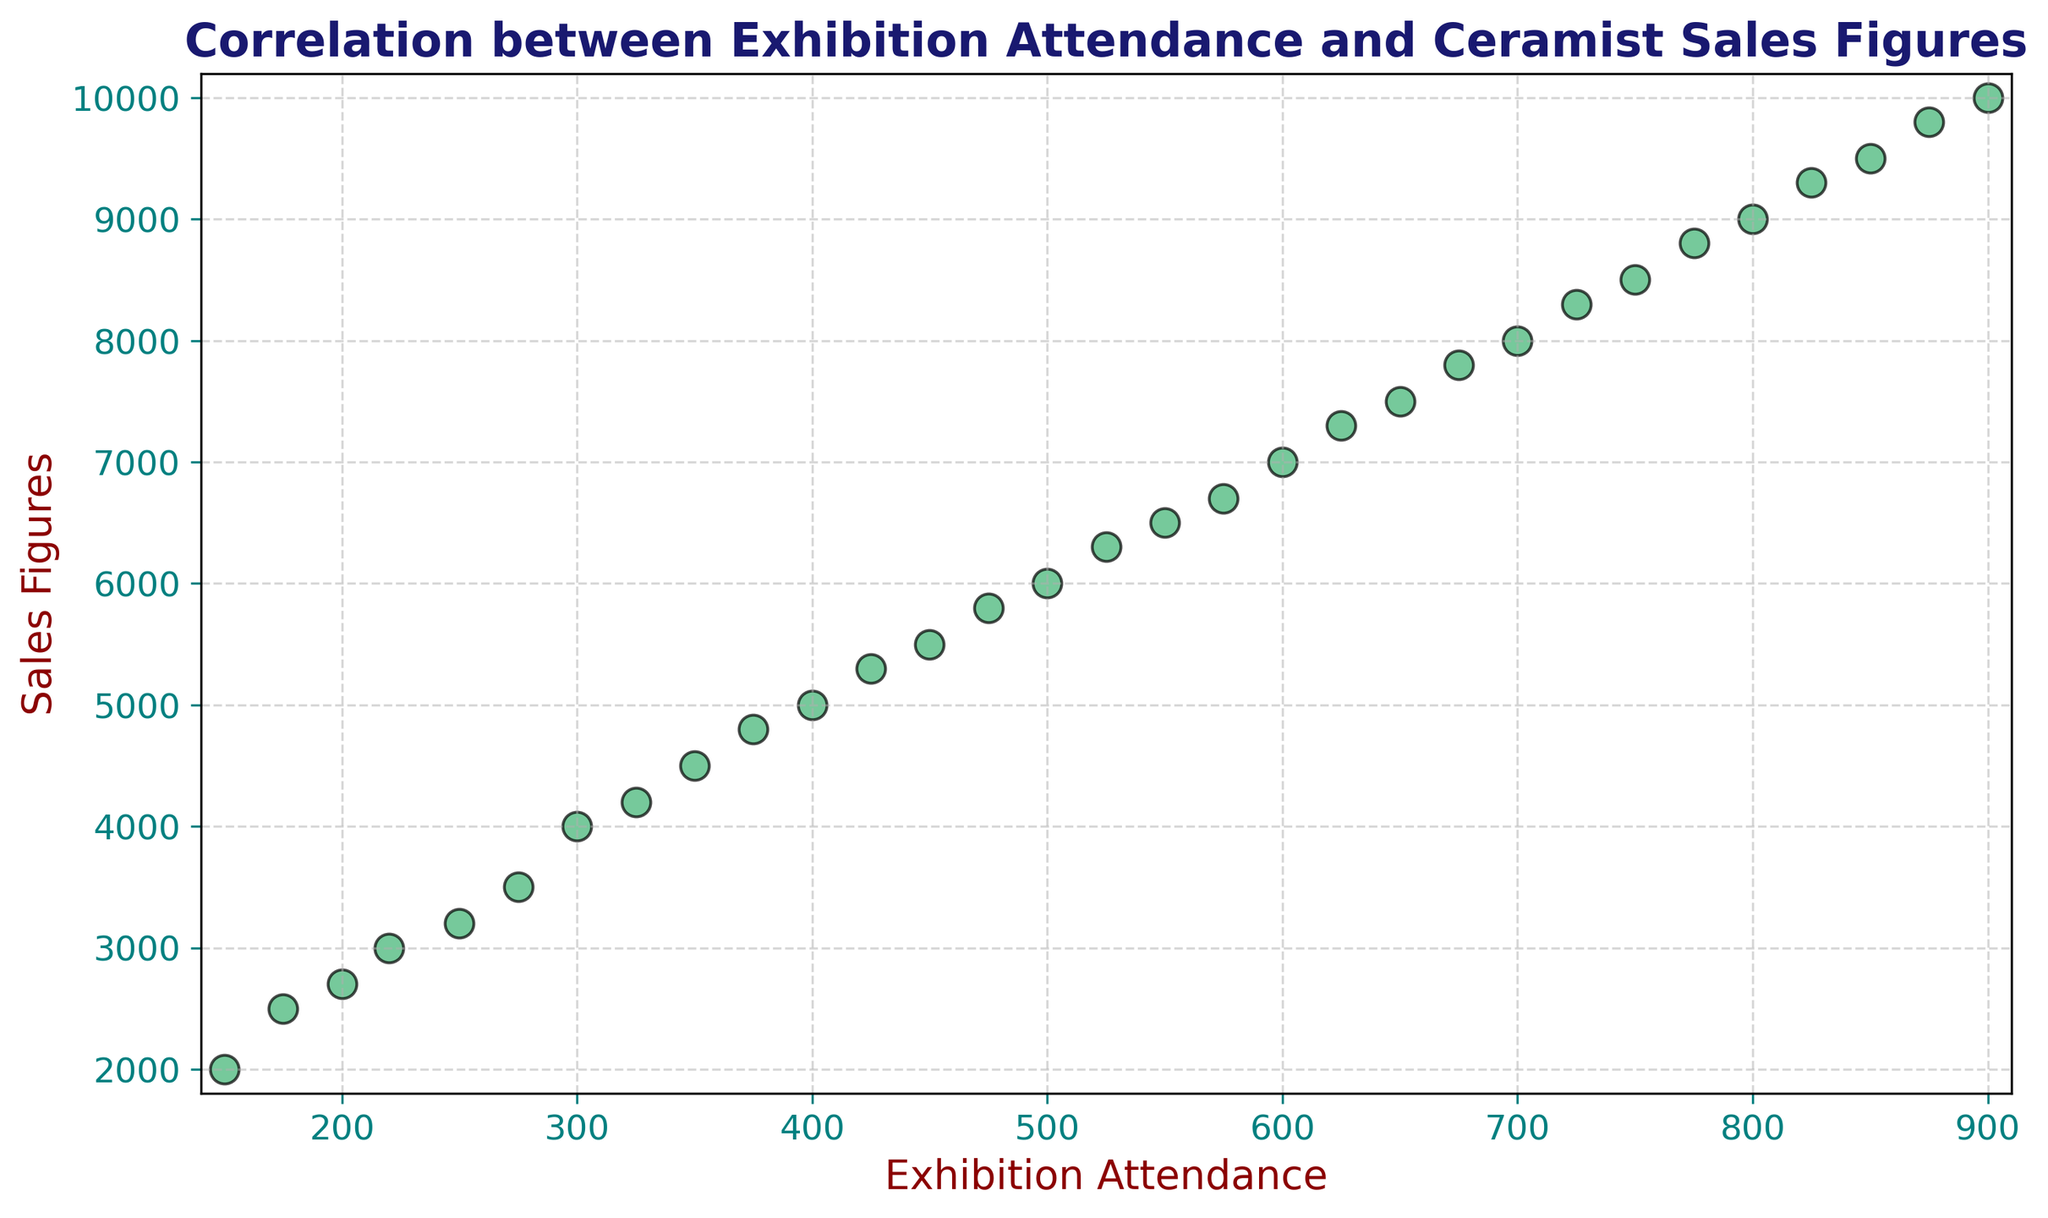What is the overall trend observed in the scatter plot? The scatter plot shows an upward trend indicating a positive correlation between Exhibition Attendance and Sales Figures. As Exhibition Attendance increases, Sales Figures also increase.
Answer: Positive correlation What is the approximate Sales Figure when the Exhibition Attendance is 400? Referring to the scatter plot, the Sales Figure for an Exhibition Attendance of 400 is close to 5000.
Answer: 5000 Which data point has the highest Sales Figure and what is the corresponding Exhibition Attendance? The data point with the highest Sales Figure is 10000, corresponding to an Exhibition Attendance of 900. This is the top-most point in the scatter plot.
Answer: Sales Figure: 10000, Exhibition Attendance: 900 Can you identify a general range for the Sales Figures when the Exhibition Attendance is between 500 and 650? Looking at the plot, the Sales Figures range from around 6000 to 7500 when the Exhibition Attendance is between 500 and 650.
Answer: 6000 to 7500 Are there any outliers that deviate significantly from the overall trend? No, there are no obvious outliers in the scatter plot. All data points follow a consistent upward trend, indicating a strong positive correlation between the variables.
Answer: No What is the difference in Sales Figures between the lowest and highest Exhibition Attendances? The Sales Figure at the lowest Exhibition Attendance (150) is 2000 and at the highest Exhibition Attendance (900) is 10000. The difference is 10000 - 2000 = 8000.
Answer: 8000 How do the Sales Figures compare between an Exhibition Attendance of 250 and 750? The Sales Figure for an Exhibition Attendance of 250 is approximately 3200 and for an Exhibition Attendance of 750, it's approximately 8500. Therefore, the Sales Figure for an Attendance of 750 is significantly higher.
Answer: Higher for 750 What can be inferred about the sales potential if the Exhibition Attendance increases by 100 from any given point? Given the upward trend, if the Exhibition Attendance increases by 100, the Sales Figures tend to increase, reflecting a strong positive correlation. For example, moving from 400 to 500 in Attendance results in an increase of about 1300 in Sales Figures.
Answer: Sales Figures increase What might be the expected Sales Figure if the Exhibition Attendance were to reach 1000 based on the trend? Extrapolating the trend line beyond the given data, it is reasonable to expect the Sales Figure to exceed 11000 if the Exhibition Attendance reaches 1000.
Answer: Exceed 11000 